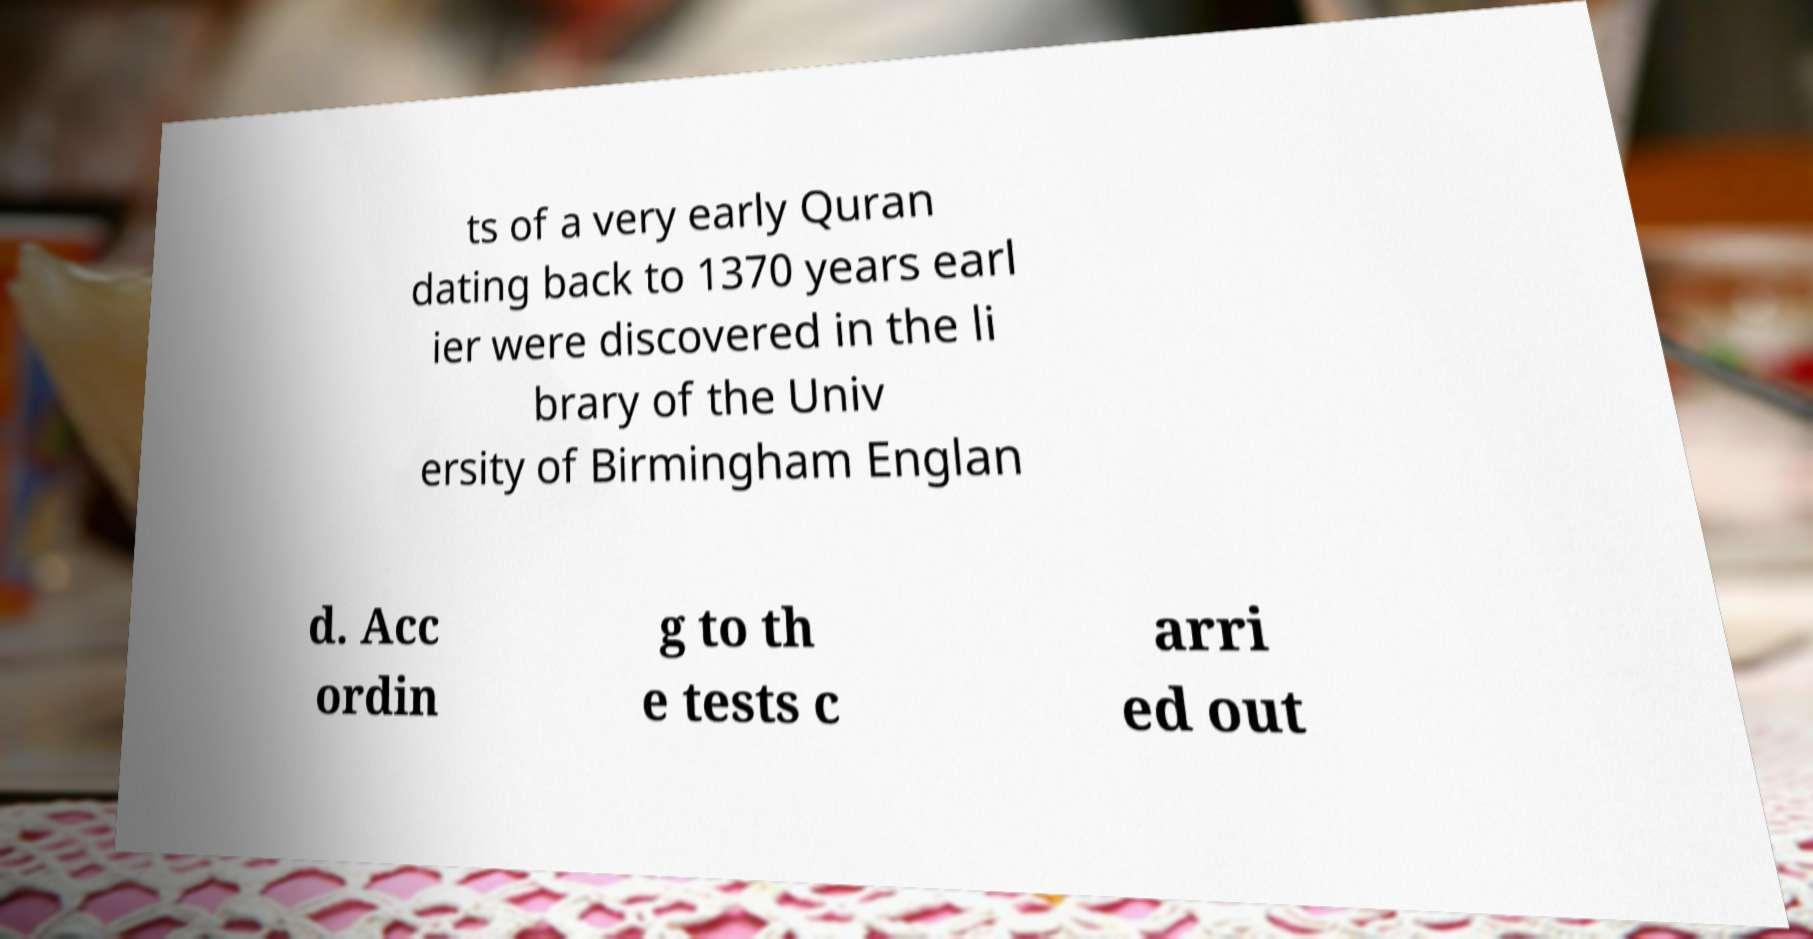Could you extract and type out the text from this image? ts of a very early Quran dating back to 1370 years earl ier were discovered in the li brary of the Univ ersity of Birmingham Englan d. Acc ordin g to th e tests c arri ed out 